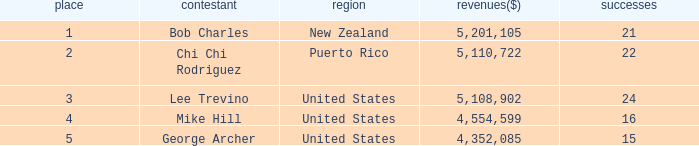In total, how much did the United States player George Archer earn with Wins lower than 24 and a rank that was higher than 5? 0.0. 